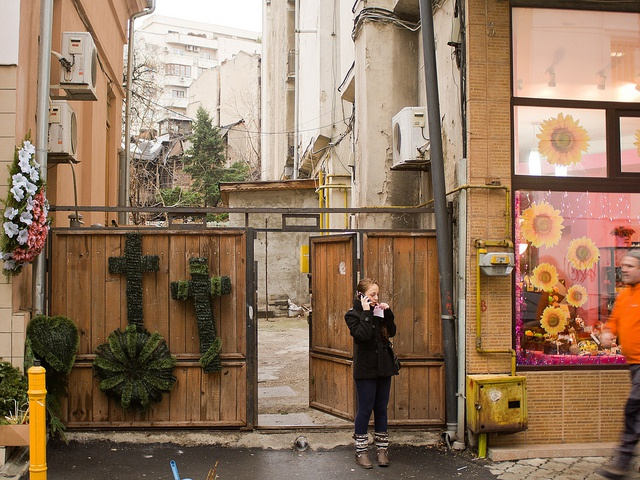Describe the objects in this image and their specific colors. I can see people in lightgray, black, gray, and maroon tones, people in lightgray, red, black, gray, and maroon tones, handbag in lightgray, black, maroon, gray, and olive tones, handbag in lightgray, black, and gray tones, and cell phone in lightgray, black, and gray tones in this image. 